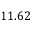<formula> <loc_0><loc_0><loc_500><loc_500>1 1 . 6 2</formula> 